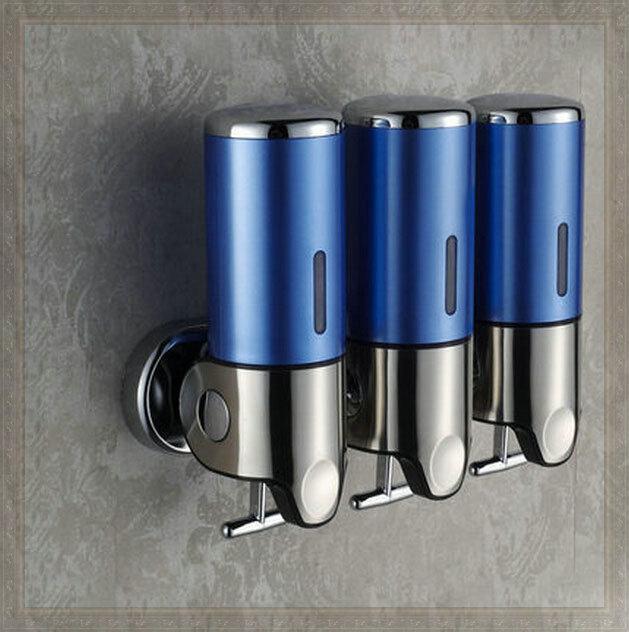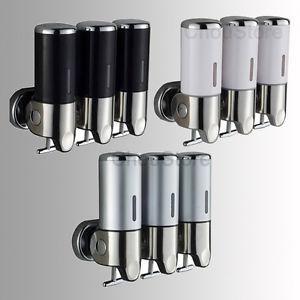The first image is the image on the left, the second image is the image on the right. Analyze the images presented: Is the assertion "All images include triple dispenser fixtures that mount on a wall, with the canisters close together side-by-side." valid? Answer yes or no. Yes. The first image is the image on the left, the second image is the image on the right. For the images shown, is this caption "In the right image three dispensers have a silvered colored solid top." true? Answer yes or no. Yes. 